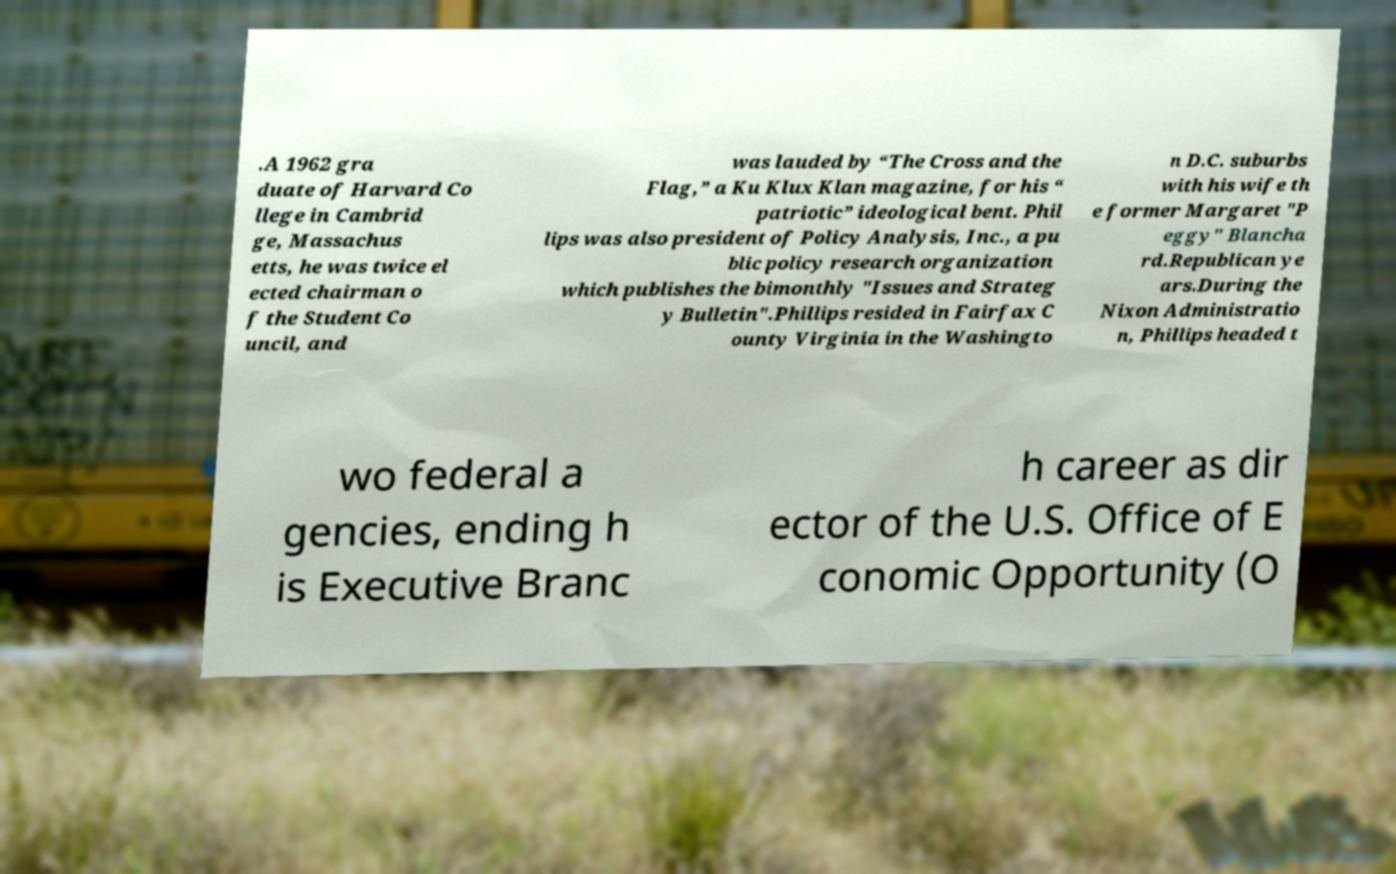For documentation purposes, I need the text within this image transcribed. Could you provide that? .A 1962 gra duate of Harvard Co llege in Cambrid ge, Massachus etts, he was twice el ected chairman o f the Student Co uncil, and was lauded by “The Cross and the Flag,” a Ku Klux Klan magazine, for his “ patriotic” ideological bent. Phil lips was also president of Policy Analysis, Inc., a pu blic policy research organization which publishes the bimonthly "Issues and Strateg y Bulletin".Phillips resided in Fairfax C ounty Virginia in the Washingto n D.C. suburbs with his wife th e former Margaret "P eggy" Blancha rd.Republican ye ars.During the Nixon Administratio n, Phillips headed t wo federal a gencies, ending h is Executive Branc h career as dir ector of the U.S. Office of E conomic Opportunity (O 